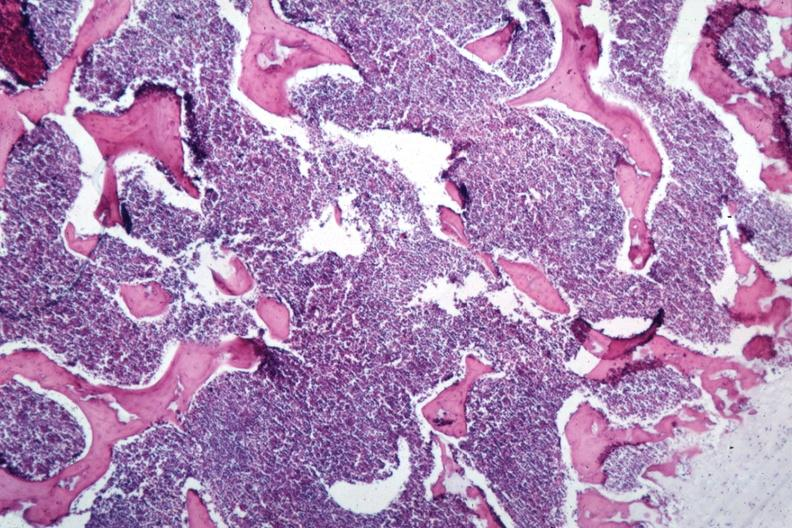does this image show sheets of lymphoma cells?
Answer the question using a single word or phrase. Yes 